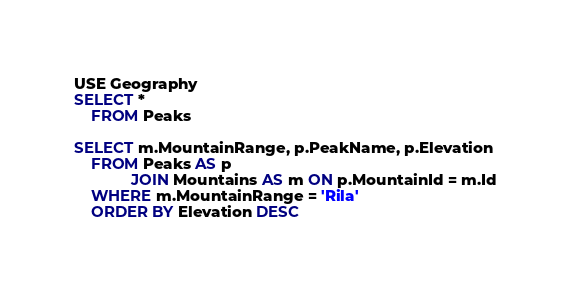<code> <loc_0><loc_0><loc_500><loc_500><_SQL_>
USE Geography
SELECT *
    FROM Peaks

SELECT m.MountainRange, p.PeakName, p.Elevation
    FROM Peaks AS p
             JOIN Mountains AS m ON p.MountainId = m.Id
    WHERE m.MountainRange = 'Rila'
    ORDER BY Elevation DESC





</code> 